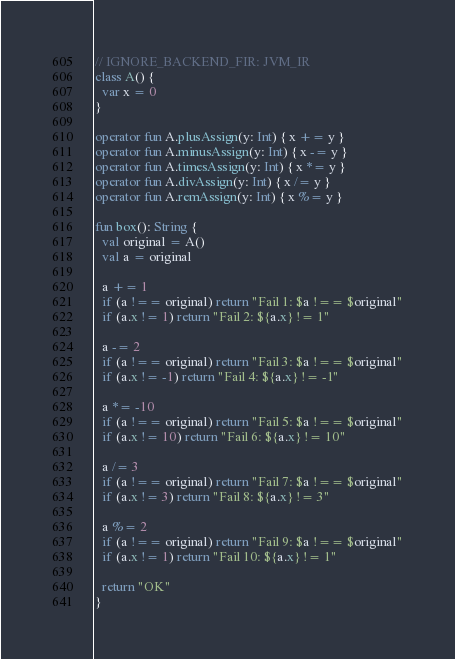Convert code to text. <code><loc_0><loc_0><loc_500><loc_500><_Kotlin_>// IGNORE_BACKEND_FIR: JVM_IR
class A() {
  var x = 0
}

operator fun A.plusAssign(y: Int) { x += y }
operator fun A.minusAssign(y: Int) { x -= y }
operator fun A.timesAssign(y: Int) { x *= y }
operator fun A.divAssign(y: Int) { x /= y }
operator fun A.remAssign(y: Int) { x %= y }

fun box(): String {
  val original = A()
  val a = original

  a += 1
  if (a !== original) return "Fail 1: $a !== $original"
  if (a.x != 1) return "Fail 2: ${a.x} != 1"

  a -= 2
  if (a !== original) return "Fail 3: $a !== $original"
  if (a.x != -1) return "Fail 4: ${a.x} != -1"

  a *= -10
  if (a !== original) return "Fail 5: $a !== $original"
  if (a.x != 10) return "Fail 6: ${a.x} != 10"

  a /= 3
  if (a !== original) return "Fail 7: $a !== $original"
  if (a.x != 3) return "Fail 8: ${a.x} != 3"

  a %= 2
  if (a !== original) return "Fail 9: $a !== $original"
  if (a.x != 1) return "Fail 10: ${a.x} != 1"

  return "OK"
}</code> 